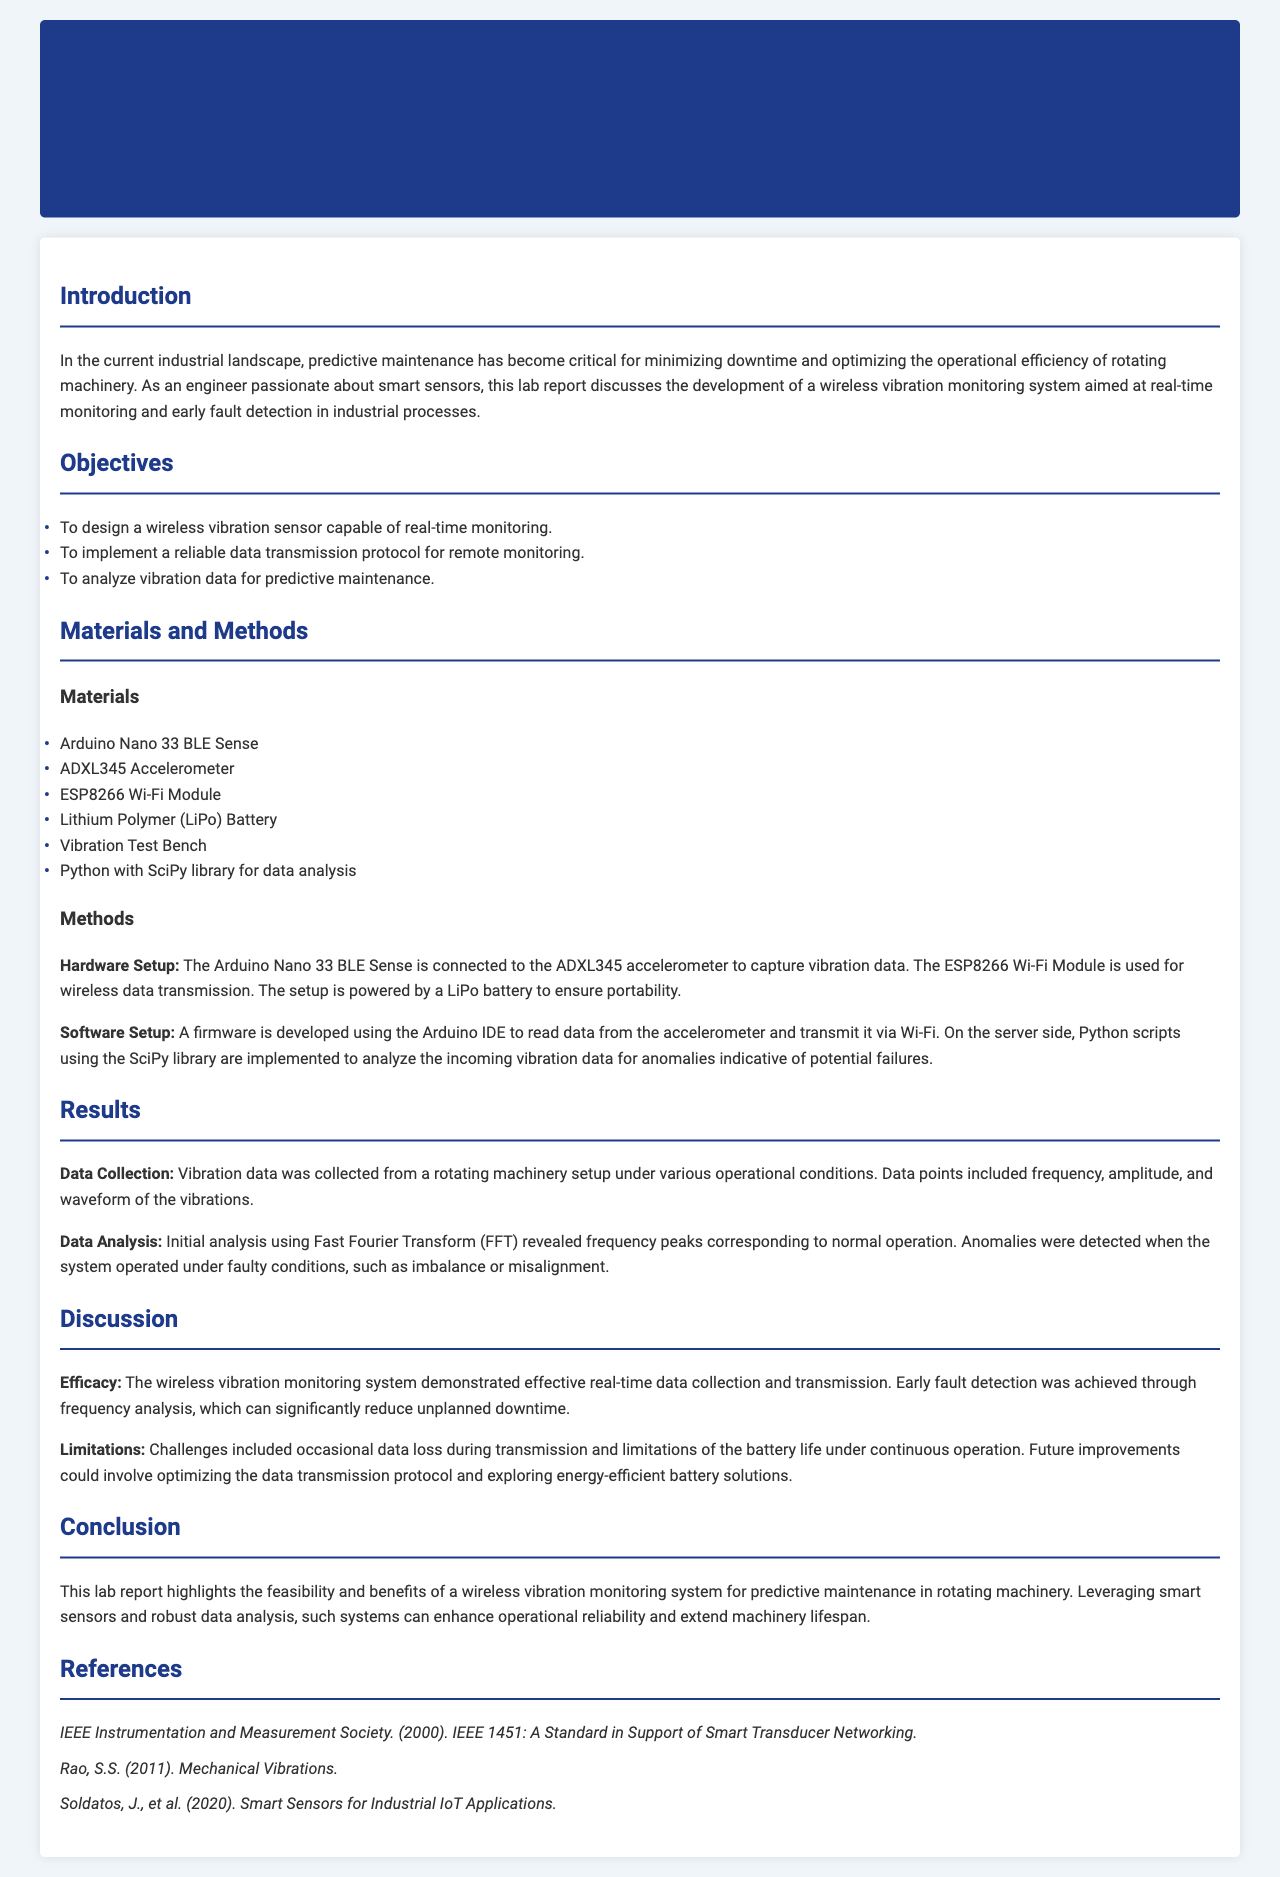What is the main purpose of the lab report? The main purpose is to discuss the development of a wireless vibration monitoring system aimed at real-time monitoring and early fault detection in industrial processes.
Answer: predictive maintenance in rotating machinery What materials were used in the project? The materials listed in the report include the Arduino Nano 33 BLE Sense, ADXL345 Accelerometer, and ESP8266 Wi-Fi Module.
Answer: Arduino Nano 33 BLE Sense What is the first objective of the project? The objectives include designing a wireless vibration sensor capable of real-time monitoring.
Answer: to design a wireless vibration sensor capable of real-time monitoring What method is used for data analysis? The report mentions using Fast Fourier Transform (FFT) for data analysis of the vibration data.
Answer: Fast Fourier Transform What was one limitation encountered in the study? The challenges included occasional data loss during transmission.
Answer: data loss during transmission What did the software setup involve? The software setup involved developing firmware using the Arduino IDE to read data and transmit it via Wi-Fi.
Answer: developing firmware using the Arduino IDE What type of analysis was performed to detect anomalies? The analysis performed to detect anomalies involved frequency analysis of the vibration data.
Answer: frequency analysis What is one potential future improvement suggested? One suggestion for future improvement is optimizing the data transmission protocol.
Answer: optimizing the data transmission protocol 